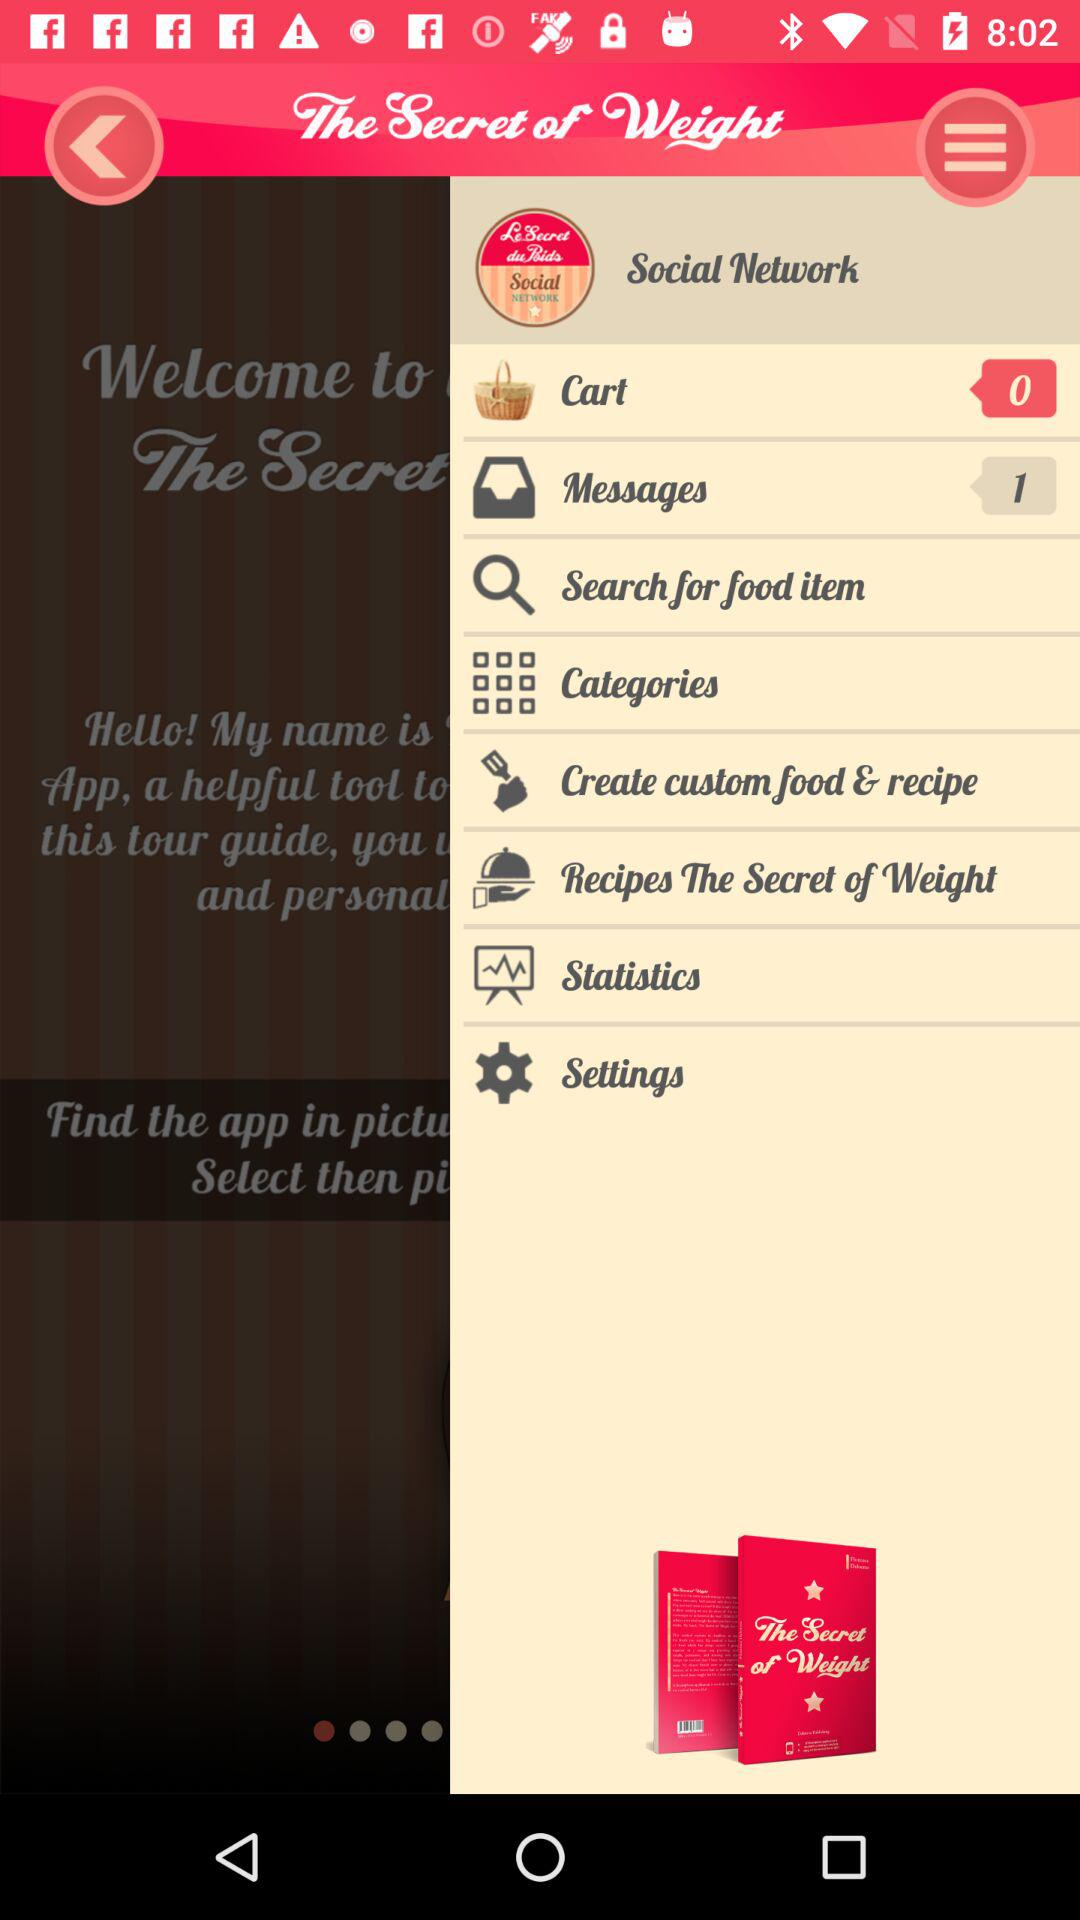How many messages are showing? There is 1 message. 